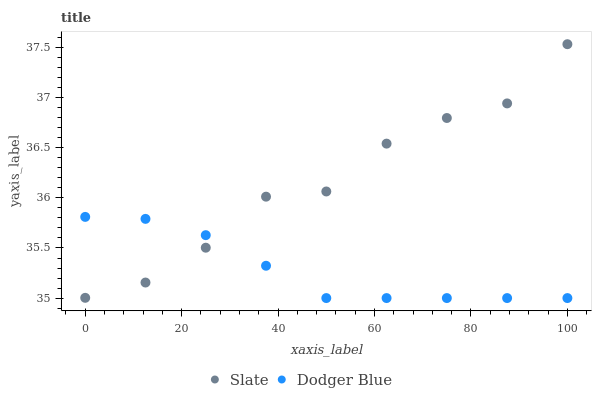Does Dodger Blue have the minimum area under the curve?
Answer yes or no. Yes. Does Slate have the maximum area under the curve?
Answer yes or no. Yes. Does Dodger Blue have the maximum area under the curve?
Answer yes or no. No. Is Dodger Blue the smoothest?
Answer yes or no. Yes. Is Slate the roughest?
Answer yes or no. Yes. Is Dodger Blue the roughest?
Answer yes or no. No. Does Dodger Blue have the lowest value?
Answer yes or no. Yes. Does Slate have the highest value?
Answer yes or no. Yes. Does Dodger Blue have the highest value?
Answer yes or no. No. Does Dodger Blue intersect Slate?
Answer yes or no. Yes. Is Dodger Blue less than Slate?
Answer yes or no. No. Is Dodger Blue greater than Slate?
Answer yes or no. No. 